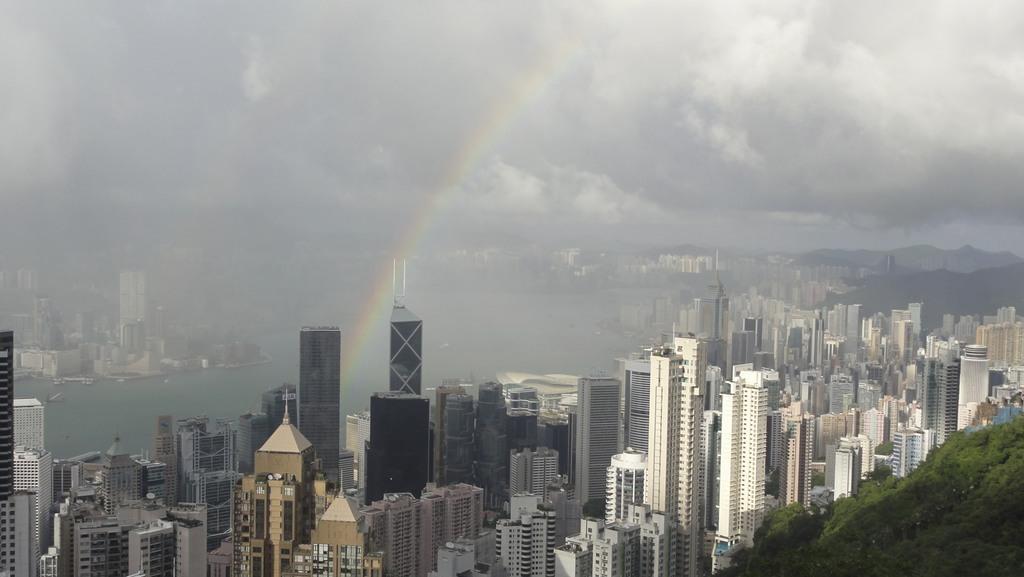How would you summarize this image in a sentence or two? In this image we can see some buildings, trees, also we can see the water, rainbow, and the cloudy sky. 